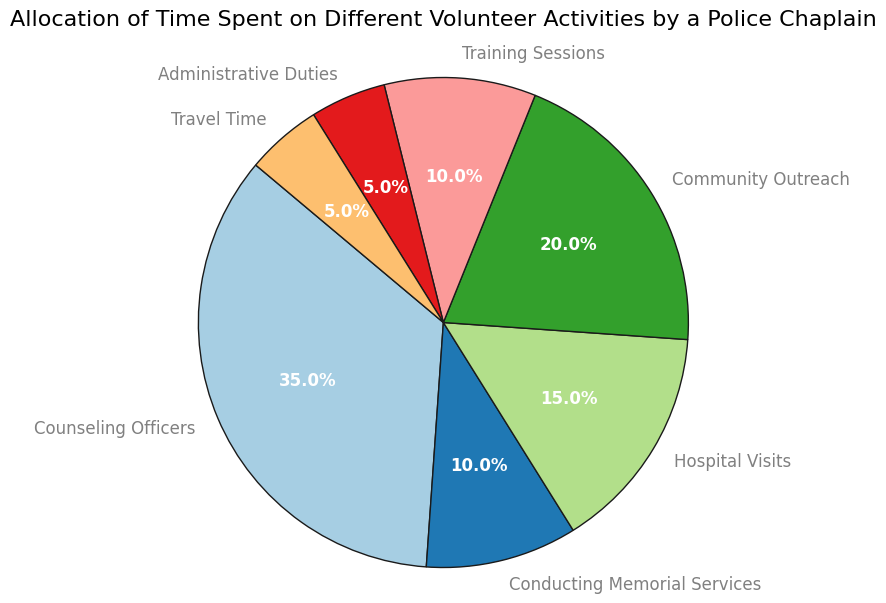Which activity takes up the most time for the police chaplain? The largest wedge in the pie chart represents the activity that takes up the most time. Here, 'Counseling Officers' has the largest percentage.
Answer: Counseling Officers Which activity is represented by a 10% segment in the pie chart? The pie chart segments labeled with 'Conducting Memorial Services' and 'Training Sessions' both show a 10% share.
Answer: Conducting Memorial Services, Training Sessions What is the combined percentage of time spent on community outreach and hospital visits? Adding the percentages for 'Community Outreach' (20%) and 'Hospital Visits' (15%) gives 35%.
Answer: 35% Which activity takes up more time: Training Sessions or Administrative Duties? Comparing the percentages for 'Training Sessions' (10%) and 'Administrative Duties' (5%) shows that 'Training Sessions' takes up more time.
Answer: Training Sessions How much more time is spent on counseling officers compared to community outreach? 'Counseling Officers' takes up 35%, and 'Community Outreach' takes up 20%. The difference is 35% - 20% = 15%.
Answer: 15% What proportion of time is spent on activities outside of direct officer interaction (Counseling Officers, Hospital Visits)? Adding the percentages for non-officer interaction activities: 'Conducting Memorial Services' (10%) + 'Community Outreach' (20%) + 'Training Sessions' (10%) + 'Administrative Duties' (5%) + 'Travel Time' (5%) = 50%.
Answer: 50% If travel time were to be increased by 5%, which other activity's percentage could be reduced to balance this change? If 'Travel Time' increases from 5% to 10%, a total of 5% must be reduced. Options could include any activity, e.g., reducing 'Counseling Officers' from 35% to 30%.
Answer: Varies (e.g., Counseling Officers) Which segments are assigned the same percentage of time? Observing the labels, 'Conducting Memorial Services' and 'Training Sessions' each have a 10% share. Additionally, 'Administrative Duties' and 'Travel Time' both have 5%.
Answer: Conducting Memorial Services, Training Sessions; Administrative Duties, Travel Time What is the smallest segment on the pie chart? The pie chart segment for 'Administrative Duties' (5%) is the smallest.
Answer: Administrative Duties 